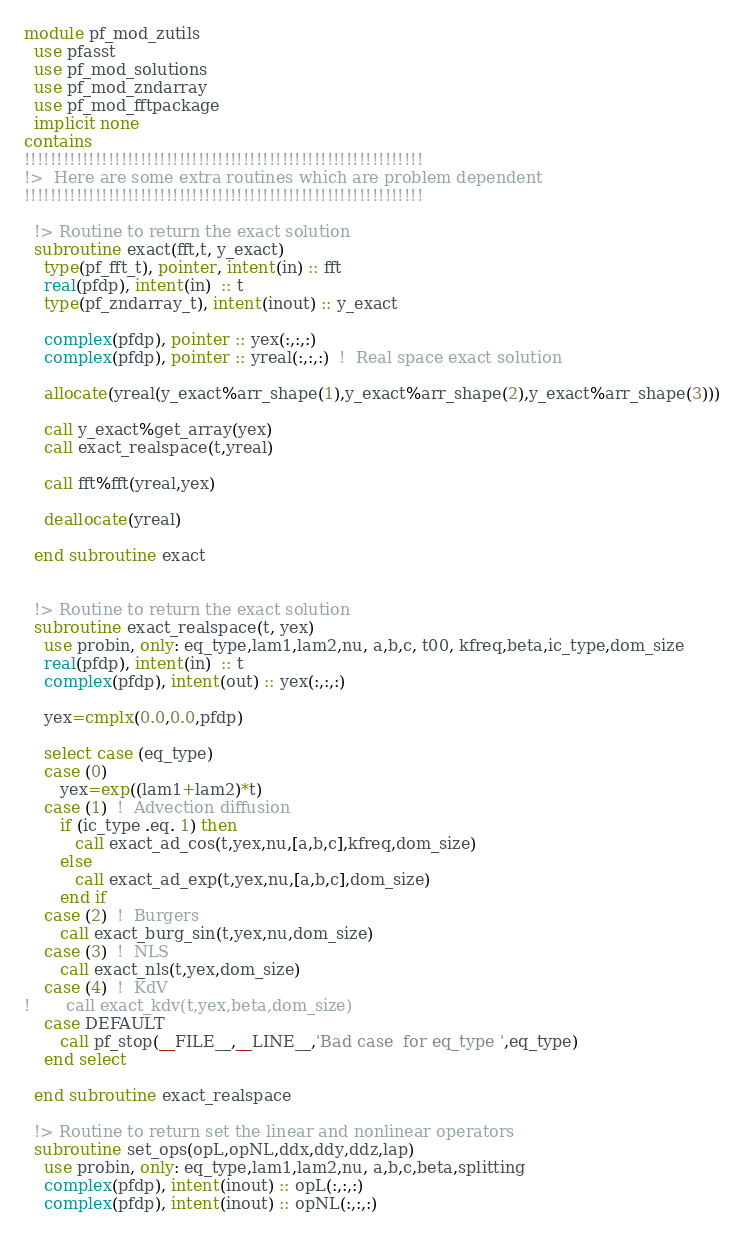Convert code to text. <code><loc_0><loc_0><loc_500><loc_500><_FORTRAN_>module pf_mod_zutils
  use pfasst
  use pf_mod_solutions
  use pf_mod_zndarray
  use pf_mod_fftpackage  
  implicit none
contains  
!!!!!!!!!!!!!!!!!!!!!!!!!!!!!!!!!!!!!!!!!!!!!!!!!!!!!!!!!!!!!!
!>  Here are some extra routines which are problem dependent  
!!!!!!!!!!!!!!!!!!!!!!!!!!!!!!!!!!!!!!!!!!!!!!!!!!!!!!!!!!!!!!

  !> Routine to return the exact solution
  subroutine exact(fft,t, y_exact)
    type(pf_fft_t), pointer, intent(in) :: fft
    real(pfdp), intent(in)  :: t
    type(pf_zndarray_t), intent(inout) :: y_exact
    
    complex(pfdp), pointer :: yex(:,:,:)
    complex(pfdp), pointer :: yreal(:,:,:)  !  Real space exact solution

    allocate(yreal(y_exact%arr_shape(1),y_exact%arr_shape(2),y_exact%arr_shape(3)))

    call y_exact%get_array(yex)    
    call exact_realspace(t,yreal)

    call fft%fft(yreal,yex)

    deallocate(yreal)
    
  end subroutine exact

  
  !> Routine to return the exact solution
  subroutine exact_realspace(t, yex)
    use probin, only: eq_type,lam1,lam2,nu, a,b,c, t00, kfreq,beta,ic_type,dom_size
    real(pfdp), intent(in)  :: t
    complex(pfdp), intent(out) :: yex(:,:,:)

    yex=cmplx(0.0,0.0,pfdp)

    select case (eq_type)
    case (0)
       yex=exp((lam1+lam2)*t)
    case (1)  !  Advection diffusion
       if (ic_type .eq. 1) then 
          call exact_ad_cos(t,yex,nu,[a,b,c],kfreq,dom_size)
       else
          call exact_ad_exp(t,yex,nu,[a,b,c],dom_size)
       end if
    case (2)  !  Burgers
       call exact_burg_sin(t,yex,nu,dom_size)
    case (3)  !  NLS
       call exact_nls(t,yex,dom_size)
    case (4)  !  KdV
!       call exact_kdv(t,yex,beta,dom_size)
    case DEFAULT
       call pf_stop(__FILE__,__LINE__,'Bad case  for eq_type ',eq_type)
    end select
    
  end subroutine exact_realspace

  !> Routine to return set the linear and nonlinear operators
  subroutine set_ops(opL,opNL,ddx,ddy,ddz,lap)
    use probin, only: eq_type,lam1,lam2,nu, a,b,c,beta,splitting
    complex(pfdp), intent(inout) :: opL(:,:,:)
    complex(pfdp), intent(inout) :: opNL(:,:,:)</code> 